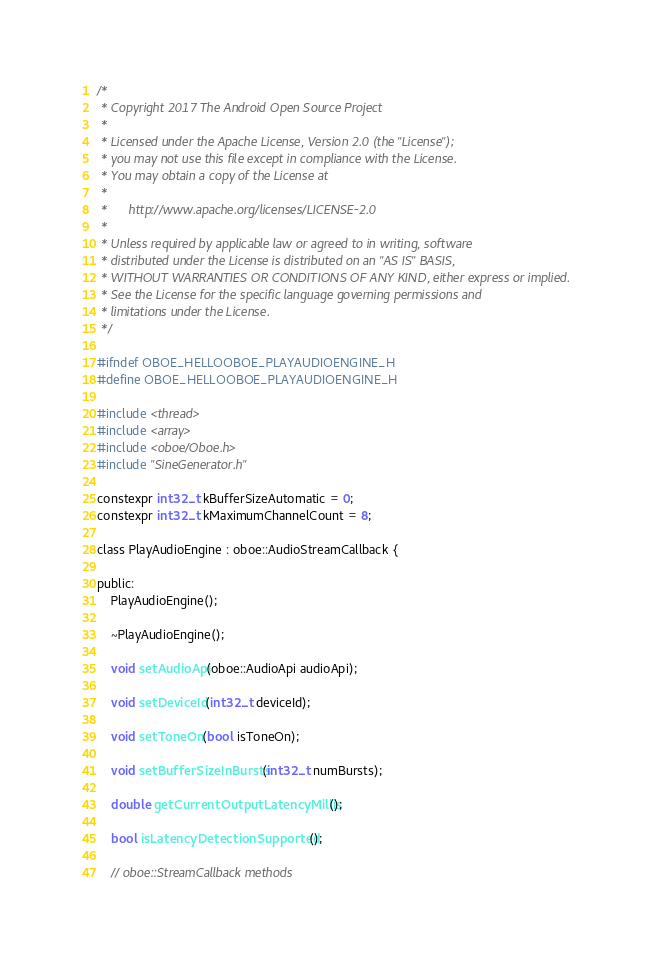Convert code to text. <code><loc_0><loc_0><loc_500><loc_500><_C_>/*
 * Copyright 2017 The Android Open Source Project
 *
 * Licensed under the Apache License, Version 2.0 (the "License");
 * you may not use this file except in compliance with the License.
 * You may obtain a copy of the License at
 *
 *      http://www.apache.org/licenses/LICENSE-2.0
 *
 * Unless required by applicable law or agreed to in writing, software
 * distributed under the License is distributed on an "AS IS" BASIS,
 * WITHOUT WARRANTIES OR CONDITIONS OF ANY KIND, either express or implied.
 * See the License for the specific language governing permissions and
 * limitations under the License.
 */

#ifndef OBOE_HELLOOBOE_PLAYAUDIOENGINE_H
#define OBOE_HELLOOBOE_PLAYAUDIOENGINE_H

#include <thread>
#include <array>
#include <oboe/Oboe.h>
#include "SineGenerator.h"

constexpr int32_t kBufferSizeAutomatic = 0;
constexpr int32_t kMaximumChannelCount = 8;

class PlayAudioEngine : oboe::AudioStreamCallback {

public:
    PlayAudioEngine();

    ~PlayAudioEngine();

    void setAudioApi(oboe::AudioApi audioApi);

    void setDeviceId(int32_t deviceId);

    void setToneOn(bool isToneOn);

    void setBufferSizeInBursts(int32_t numBursts);

    double getCurrentOutputLatencyMillis();

    bool isLatencyDetectionSupported();

    // oboe::StreamCallback methods</code> 